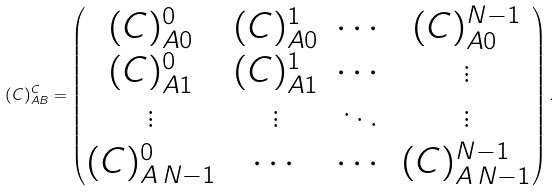<formula> <loc_0><loc_0><loc_500><loc_500>( C ) _ { A B } ^ { C } = \begin{pmatrix} ( C ) _ { A 0 } ^ { 0 } & ( C ) _ { A 0 } ^ { 1 } & \cdots & ( C ) _ { A 0 } ^ { N - 1 } \\ ( C ) _ { A 1 } ^ { 0 } & ( C ) _ { A 1 } ^ { 1 } & \cdots & \vdots \\ \vdots & \vdots & \ddots & \vdots \\ ( C ) _ { A \, N - 1 } ^ { 0 } & \cdots & \cdots & ( C ) _ { A \, N - 1 } ^ { N - 1 } \end{pmatrix} .</formula> 